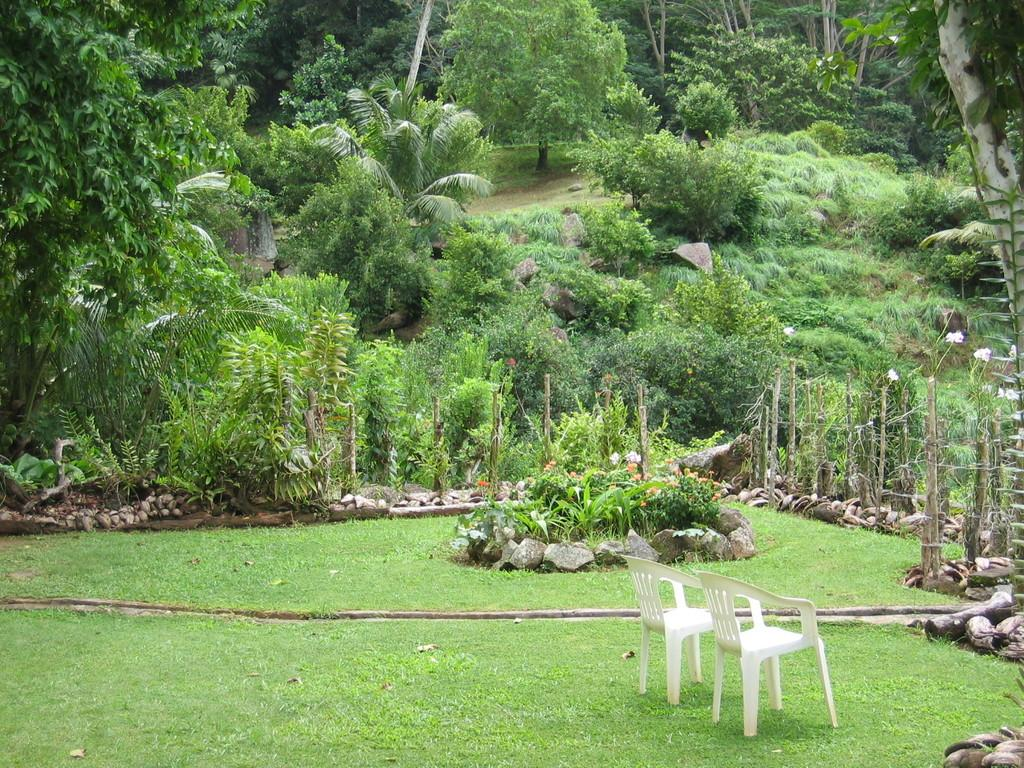What objects are placed on the ground in the image? There are chairs placed on the ground in the image. What type of vegetation can be seen in the image? There is grass, a group of plants, flowers, and a group of trees visible in the image. What other materials can be seen in the image? There are wooden poles and stones in the image. What is the distance between the hill and the middle of the image? There is no hill present in the image, so it is not possible to determine the distance between a hill and the middle of the image. 